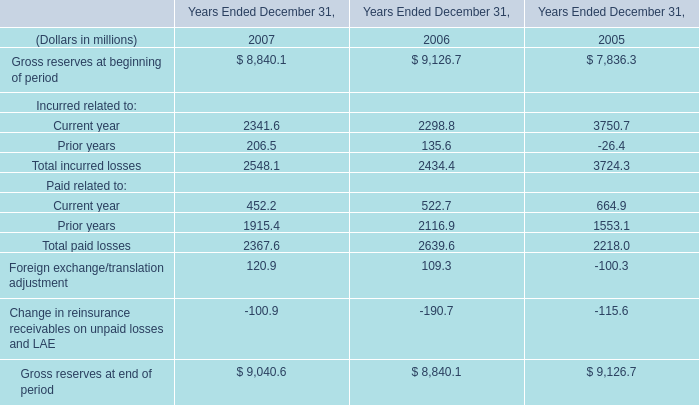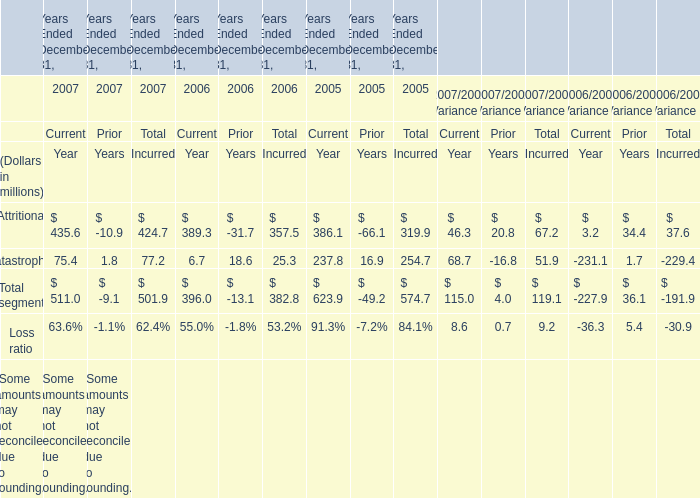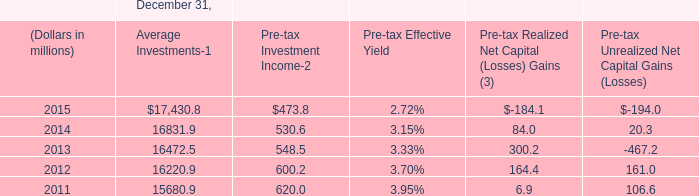Which year is Attritional for Total Incurred the most? 
Answer: 2007. 